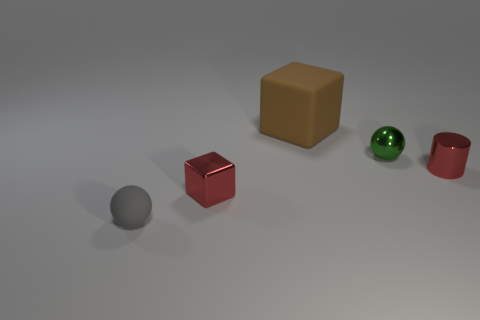Is there anything else that is the same size as the rubber block?
Make the answer very short. No. Do the matte object in front of the red cylinder and the matte thing that is behind the tiny gray rubber sphere have the same shape?
Offer a terse response. No. How many other things are the same material as the big block?
Your answer should be compact. 1. Is the object on the left side of the tiny block made of the same material as the tiny red object that is on the right side of the big brown block?
Provide a short and direct response. No. What shape is the tiny red object that is the same material as the small cylinder?
Make the answer very short. Cube. Is there anything else of the same color as the tiny metal block?
Your response must be concise. Yes. What number of yellow spheres are there?
Make the answer very short. 0. There is a small object that is both on the left side of the green metallic object and behind the gray rubber sphere; what is its shape?
Provide a short and direct response. Cube. The red object that is in front of the red thing on the right side of the matte thing behind the small rubber ball is what shape?
Make the answer very short. Cube. The small thing that is both in front of the cylinder and behind the tiny gray rubber thing is made of what material?
Keep it short and to the point. Metal. 